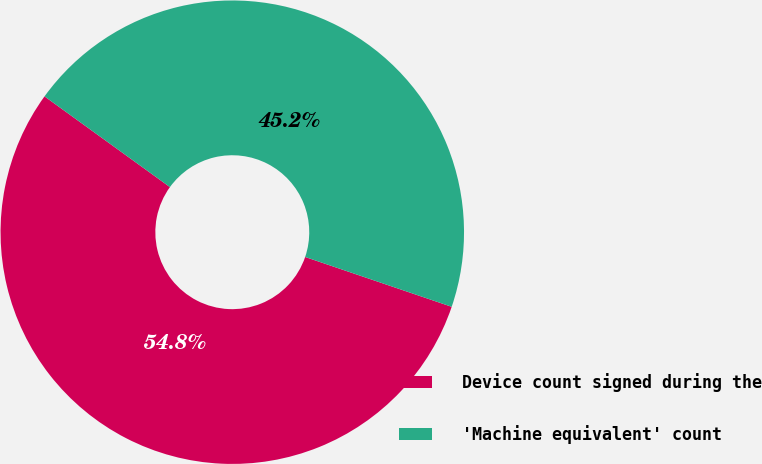<chart> <loc_0><loc_0><loc_500><loc_500><pie_chart><fcel>Device count signed during the<fcel>'Machine equivalent' count<nl><fcel>54.75%<fcel>45.25%<nl></chart> 